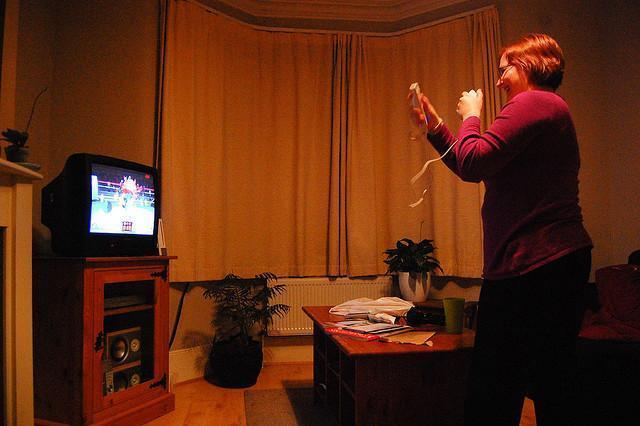How many people are in the room?
Give a very brief answer. 1. How many potted plants are visible?
Give a very brief answer. 2. How many cars do you see?
Give a very brief answer. 0. 